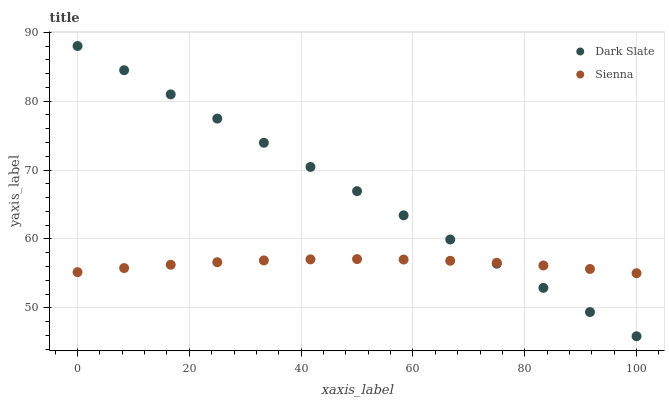Does Sienna have the minimum area under the curve?
Answer yes or no. Yes. Does Dark Slate have the maximum area under the curve?
Answer yes or no. Yes. Does Dark Slate have the minimum area under the curve?
Answer yes or no. No. Is Dark Slate the smoothest?
Answer yes or no. Yes. Is Sienna the roughest?
Answer yes or no. Yes. Is Dark Slate the roughest?
Answer yes or no. No. Does Dark Slate have the lowest value?
Answer yes or no. Yes. Does Dark Slate have the highest value?
Answer yes or no. Yes. Does Dark Slate intersect Sienna?
Answer yes or no. Yes. Is Dark Slate less than Sienna?
Answer yes or no. No. Is Dark Slate greater than Sienna?
Answer yes or no. No. 